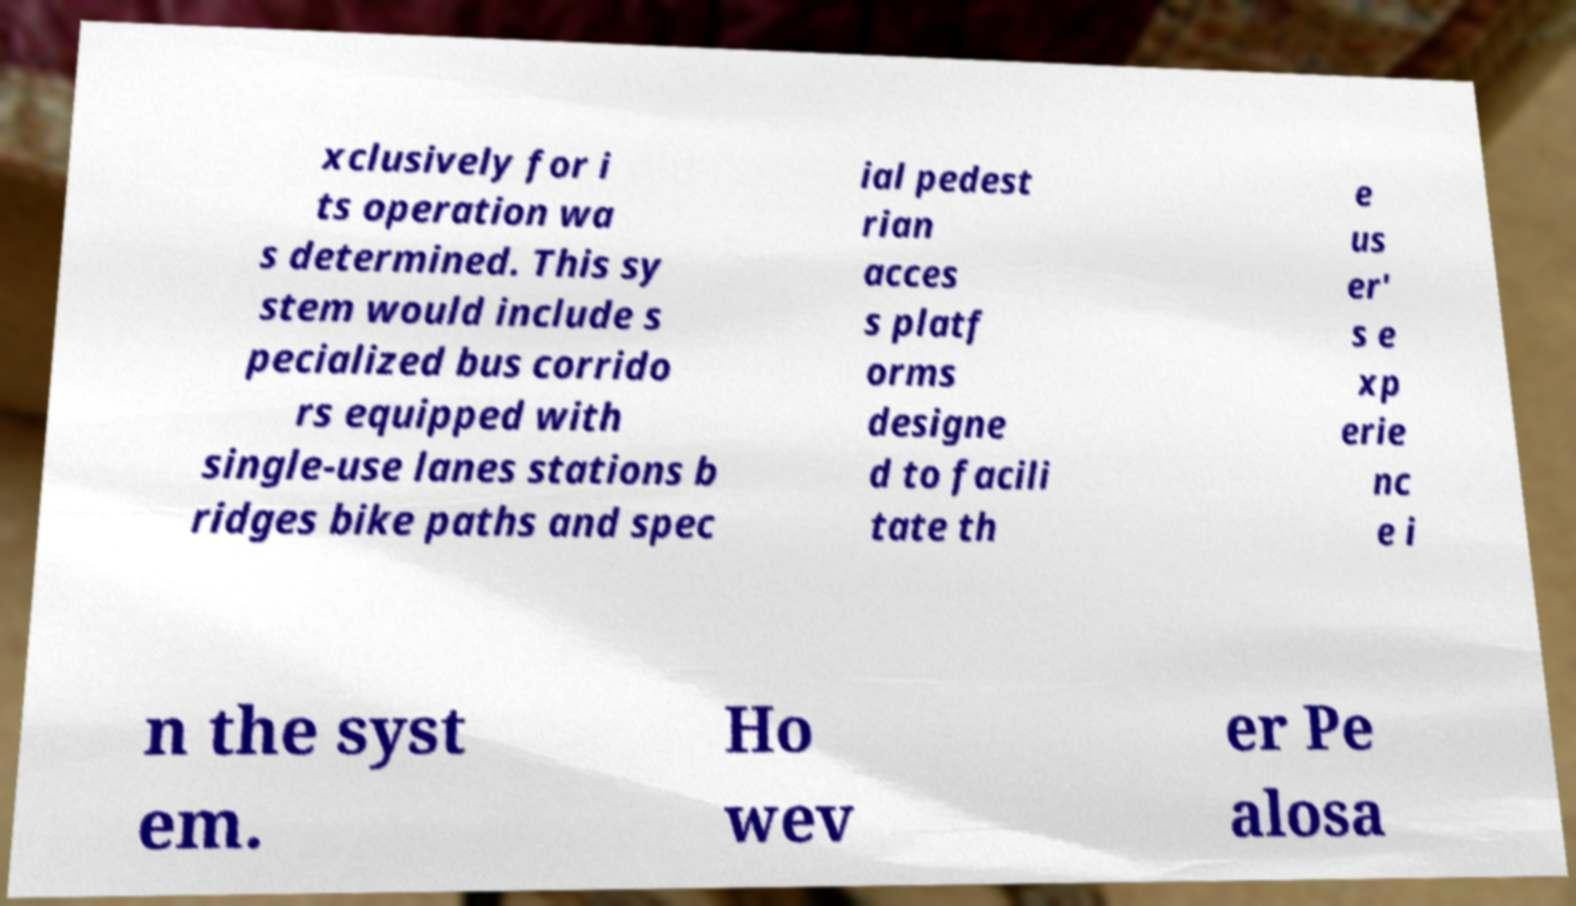Could you assist in decoding the text presented in this image and type it out clearly? xclusively for i ts operation wa s determined. This sy stem would include s pecialized bus corrido rs equipped with single-use lanes stations b ridges bike paths and spec ial pedest rian acces s platf orms designe d to facili tate th e us er' s e xp erie nc e i n the syst em. Ho wev er Pe alosa 